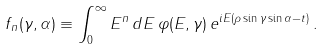Convert formula to latex. <formula><loc_0><loc_0><loc_500><loc_500>f _ { n } ( \gamma , \alpha ) \equiv \int _ { 0 } ^ { \infty } E ^ { n } \, d E \, \varphi ( E , \gamma ) \, e ^ { i E ( \rho \sin \gamma \sin \alpha - t ) } \, .</formula> 